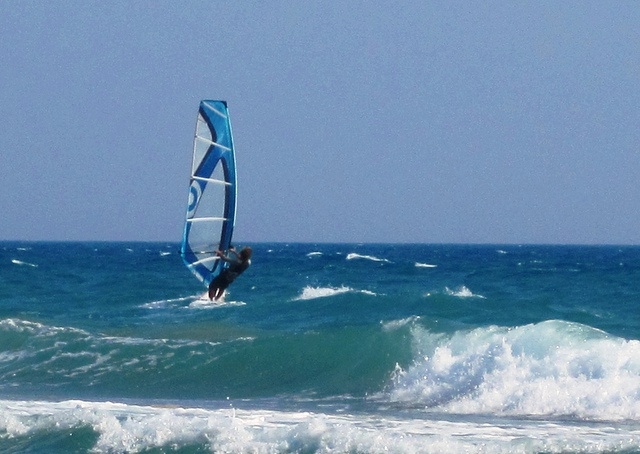Describe the objects in this image and their specific colors. I can see people in darkgray, black, navy, blue, and gray tones and surfboard in darkgray, lightgray, and gray tones in this image. 